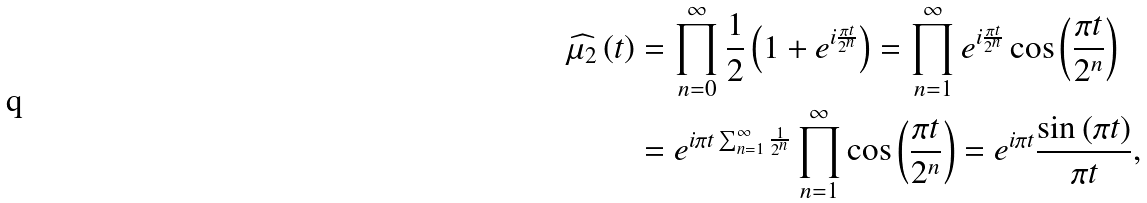<formula> <loc_0><loc_0><loc_500><loc_500>\widehat { \mu _ { 2 } } \left ( t \right ) & = \prod _ { n = 0 } ^ { \infty } \frac { 1 } { 2 } \left ( 1 + e ^ { i \frac { \pi t } { 2 ^ { n } } } \right ) = \prod _ { n = 1 } ^ { \infty } e ^ { i \frac { \pi t } { 2 ^ { n } } } \cos \left ( \frac { \pi t } { 2 ^ { n } } \right ) \\ & = e ^ { i \pi t \sum _ { n = 1 } ^ { \infty } \frac { 1 } { 2 ^ { n } } } \prod _ { n = 1 } ^ { \infty } \cos \left ( \frac { \pi t } { 2 ^ { n } } \right ) = e ^ { i \pi t } \frac { \sin \left ( \pi t \right ) } { \pi t } ,</formula> 